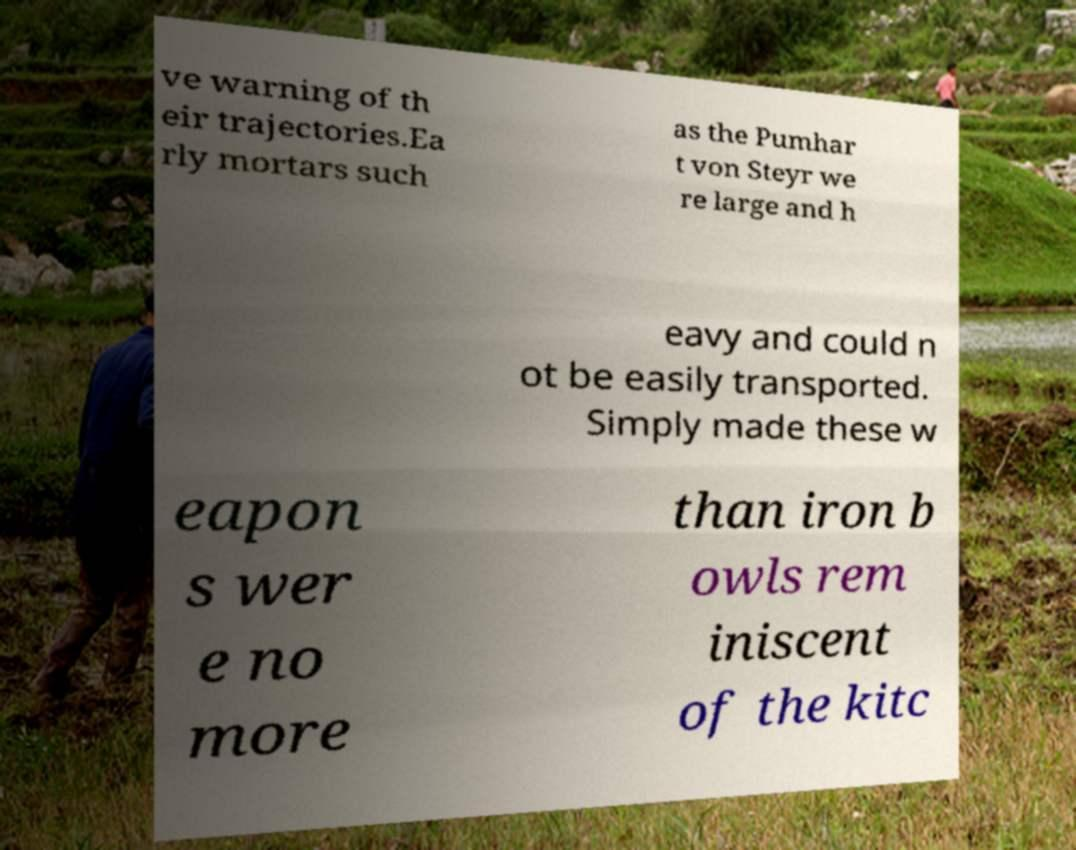For documentation purposes, I need the text within this image transcribed. Could you provide that? ve warning of th eir trajectories.Ea rly mortars such as the Pumhar t von Steyr we re large and h eavy and could n ot be easily transported. Simply made these w eapon s wer e no more than iron b owls rem iniscent of the kitc 